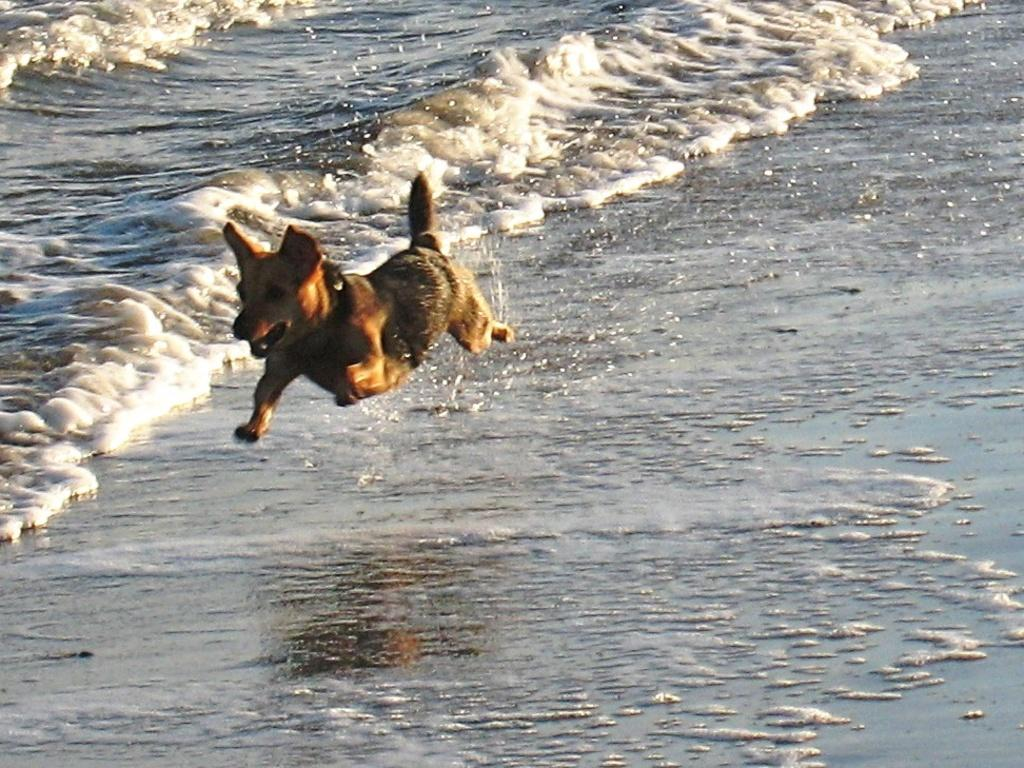What animal is present in the image? There is a dog in the image. What is the dog doing in the image? The dog is running on the water. How many cents are visible in the image? There are no cents present in the image. Are there any fairies flying around the dog in the image? There are no fairies present in the image. 